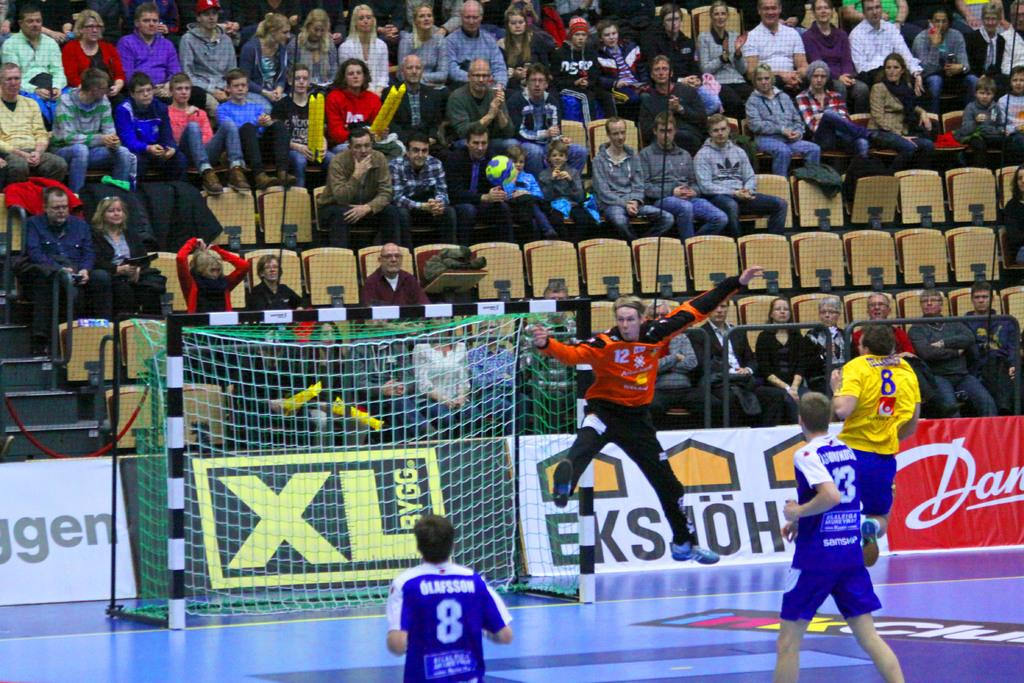<image>
Present a compact description of the photo's key features. the number 8 is on the back of a jersey 